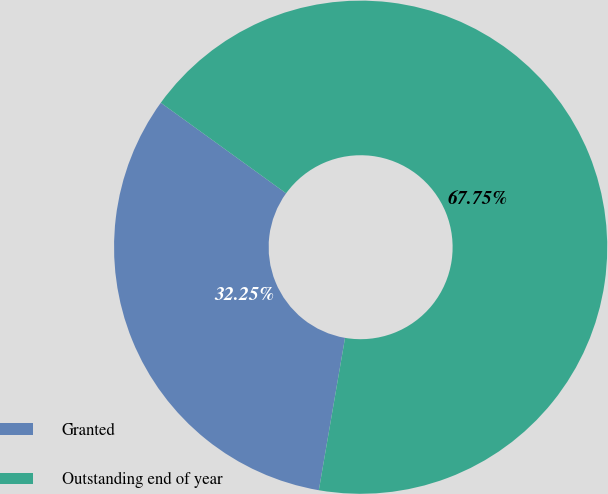<chart> <loc_0><loc_0><loc_500><loc_500><pie_chart><fcel>Granted<fcel>Outstanding end of year<nl><fcel>32.25%<fcel>67.75%<nl></chart> 